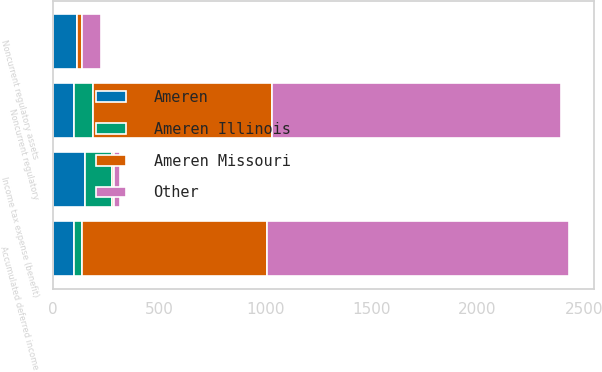<chart> <loc_0><loc_0><loc_500><loc_500><stacked_bar_chart><ecel><fcel>Accumulated deferred income<fcel>Income tax expense (benefit)<fcel>Noncurrent regulatory assets<fcel>Noncurrent regulatory<nl><fcel>Other<fcel>1419<fcel>32<fcel>89<fcel>1362<nl><fcel>Ameren Missouri<fcel>871<fcel>5<fcel>24<fcel>842<nl><fcel>Ameren Illinois<fcel>37<fcel>127<fcel>1<fcel>89<nl><fcel>Ameren<fcel>101.5<fcel>154<fcel>114<fcel>101.5<nl></chart> 